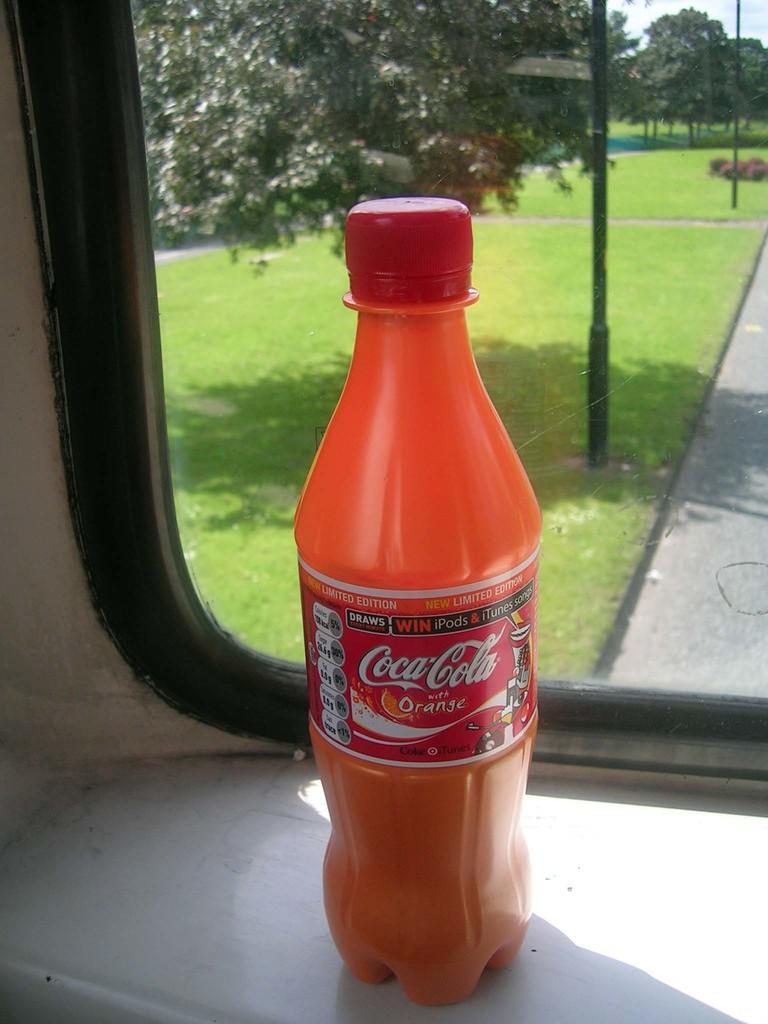What is the flavor of the beverage?
Make the answer very short. Orange. What brand is this soda?
Your response must be concise. Coca-cola. 